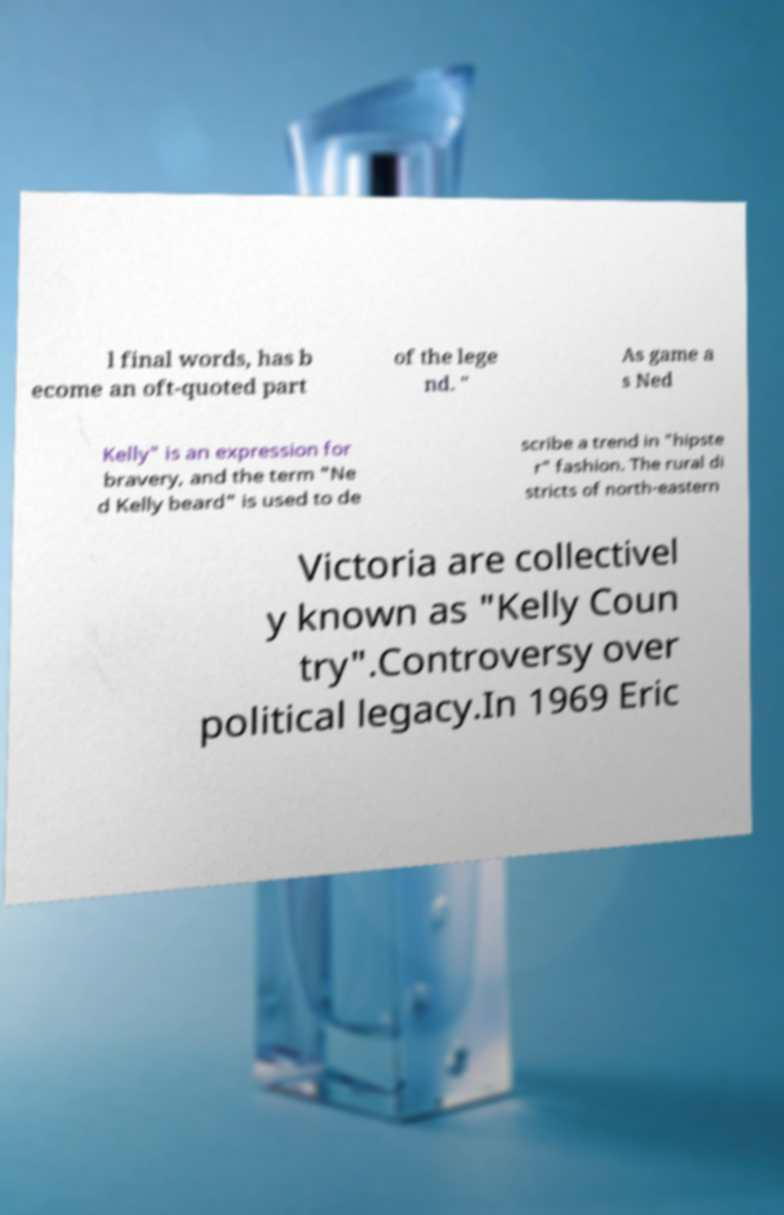Can you accurately transcribe the text from the provided image for me? l final words, has b ecome an oft-quoted part of the lege nd. " As game a s Ned Kelly" is an expression for bravery, and the term "Ne d Kelly beard" is used to de scribe a trend in "hipste r" fashion. The rural di stricts of north-eastern Victoria are collectivel y known as "Kelly Coun try".Controversy over political legacy.In 1969 Eric 